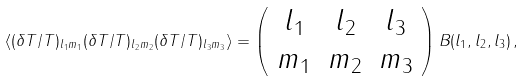Convert formula to latex. <formula><loc_0><loc_0><loc_500><loc_500>\langle ( \delta T / T ) _ { l _ { 1 } m _ { 1 } } ( \delta T / T ) _ { l _ { 2 } m _ { 2 } } ( \delta T / T ) _ { l _ { 3 } m _ { 3 } } \rangle = \left ( \begin{array} { c c c } l _ { 1 } & l _ { 2 } & l _ { 3 } \\ m _ { 1 } & m _ { 2 } & m _ { 3 } \end{array} \right ) B ( l _ { 1 } , l _ { 2 } , l _ { 3 } ) \, ,</formula> 